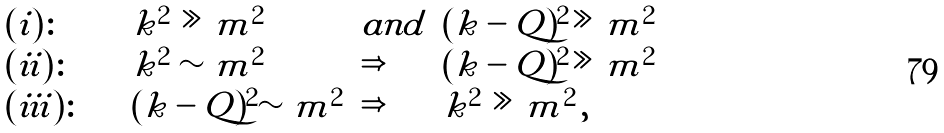<formula> <loc_0><loc_0><loc_500><loc_500>\begin{array} { l l l l } ( i ) \colon \quad & k ^ { 2 } \gg m ^ { 2 } \quad & a n d & ( k - Q ) ^ { 2 } \gg m ^ { 2 } \\ ( i i ) \colon \quad & k ^ { 2 } \sim m ^ { 2 } & \Rightarrow & ( k - Q ) ^ { 2 } \gg m ^ { 2 } \\ ( i i i ) \colon \quad & ( k - Q ) ^ { 2 } \sim m ^ { 2 } & \Rightarrow & k ^ { 2 } \gg m ^ { 2 } \, , \end{array}</formula> 